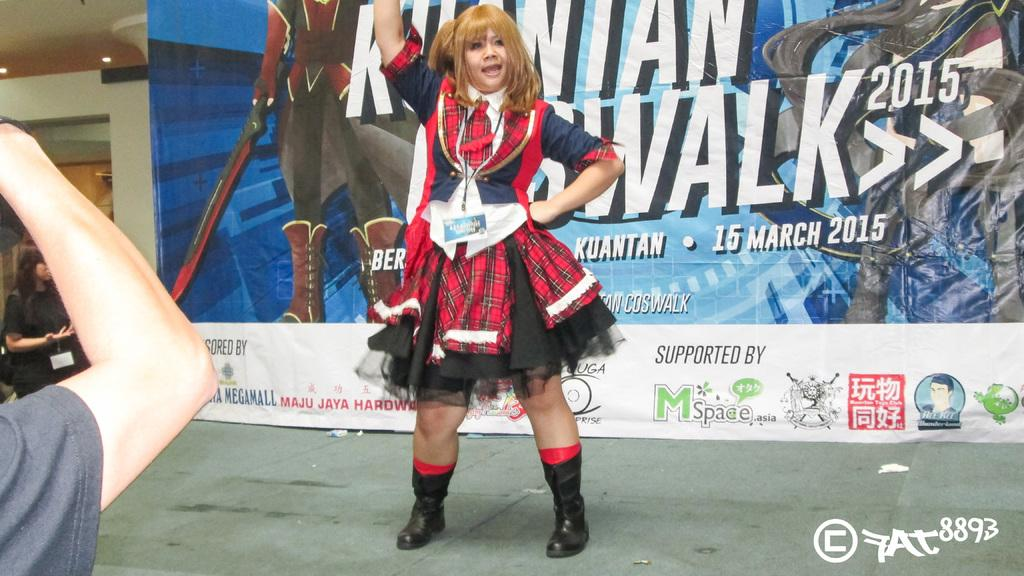<image>
Summarize the visual content of the image. A woman standing in front of a billboard with the date 15 March 2015 on it . 